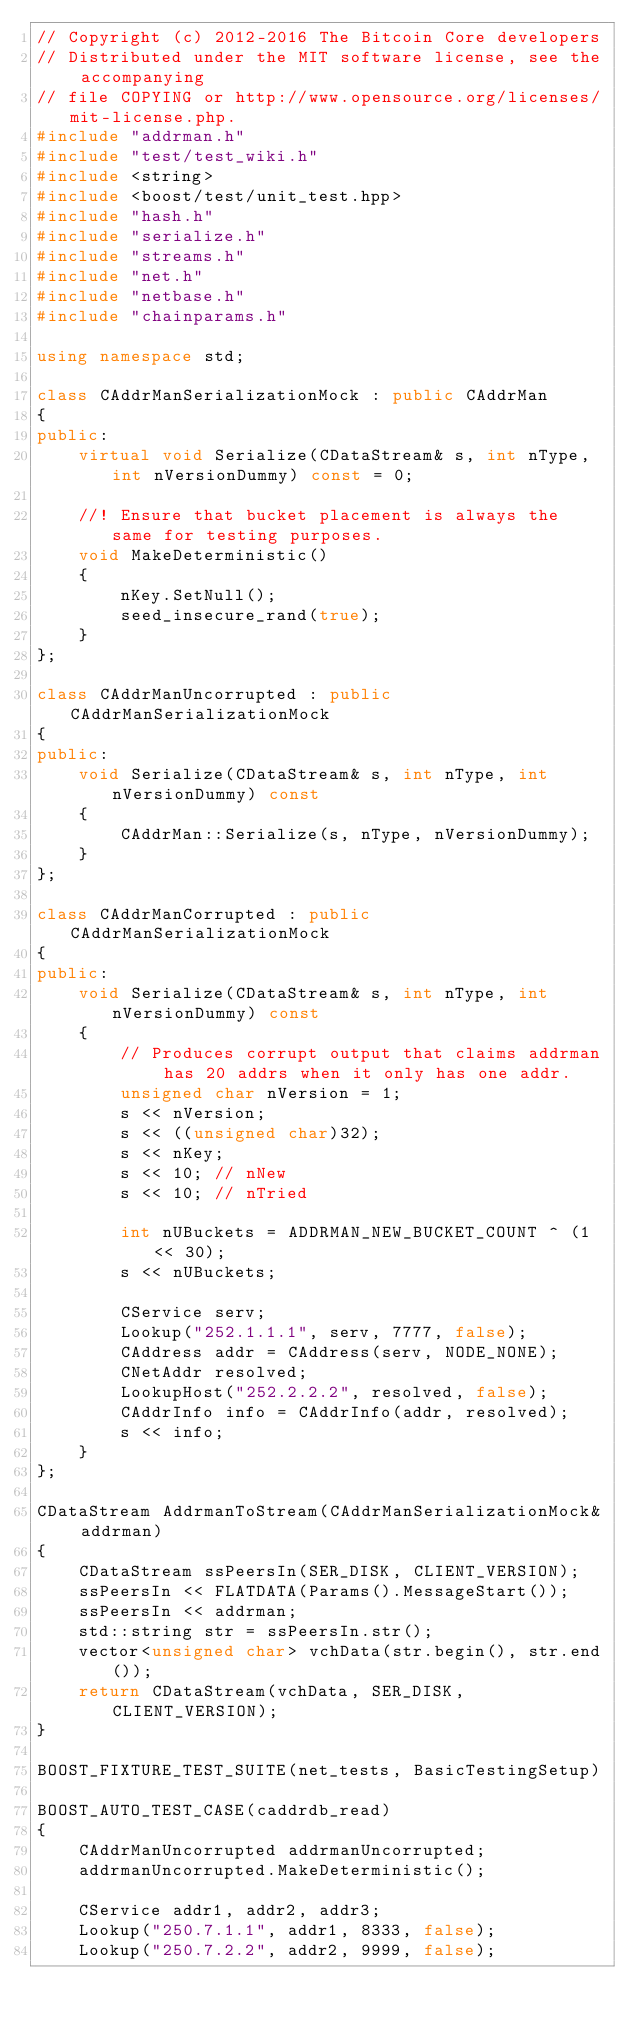<code> <loc_0><loc_0><loc_500><loc_500><_C++_>// Copyright (c) 2012-2016 The Bitcoin Core developers
// Distributed under the MIT software license, see the accompanying
// file COPYING or http://www.opensource.org/licenses/mit-license.php.
#include "addrman.h"
#include "test/test_wiki.h"
#include <string>
#include <boost/test/unit_test.hpp>
#include "hash.h"
#include "serialize.h"
#include "streams.h"
#include "net.h"
#include "netbase.h"
#include "chainparams.h"

using namespace std;

class CAddrManSerializationMock : public CAddrMan
{
public:
    virtual void Serialize(CDataStream& s, int nType, int nVersionDummy) const = 0;

    //! Ensure that bucket placement is always the same for testing purposes.
    void MakeDeterministic()
    {
        nKey.SetNull();
        seed_insecure_rand(true);
    }
};

class CAddrManUncorrupted : public CAddrManSerializationMock
{
public:
    void Serialize(CDataStream& s, int nType, int nVersionDummy) const
    {
        CAddrMan::Serialize(s, nType, nVersionDummy);
    }
};

class CAddrManCorrupted : public CAddrManSerializationMock
{
public:
    void Serialize(CDataStream& s, int nType, int nVersionDummy) const
    {
        // Produces corrupt output that claims addrman has 20 addrs when it only has one addr.
        unsigned char nVersion = 1;
        s << nVersion;
        s << ((unsigned char)32);
        s << nKey;
        s << 10; // nNew
        s << 10; // nTried

        int nUBuckets = ADDRMAN_NEW_BUCKET_COUNT ^ (1 << 30);
        s << nUBuckets;

        CService serv;
        Lookup("252.1.1.1", serv, 7777, false);
        CAddress addr = CAddress(serv, NODE_NONE);
        CNetAddr resolved;
        LookupHost("252.2.2.2", resolved, false);
        CAddrInfo info = CAddrInfo(addr, resolved);
        s << info;
    }
};

CDataStream AddrmanToStream(CAddrManSerializationMock& addrman)
{
    CDataStream ssPeersIn(SER_DISK, CLIENT_VERSION);
    ssPeersIn << FLATDATA(Params().MessageStart());
    ssPeersIn << addrman;
    std::string str = ssPeersIn.str();
    vector<unsigned char> vchData(str.begin(), str.end());
    return CDataStream(vchData, SER_DISK, CLIENT_VERSION);
}

BOOST_FIXTURE_TEST_SUITE(net_tests, BasicTestingSetup)

BOOST_AUTO_TEST_CASE(caddrdb_read)
{
    CAddrManUncorrupted addrmanUncorrupted;
    addrmanUncorrupted.MakeDeterministic();

    CService addr1, addr2, addr3;
    Lookup("250.7.1.1", addr1, 8333, false);
    Lookup("250.7.2.2", addr2, 9999, false);</code> 